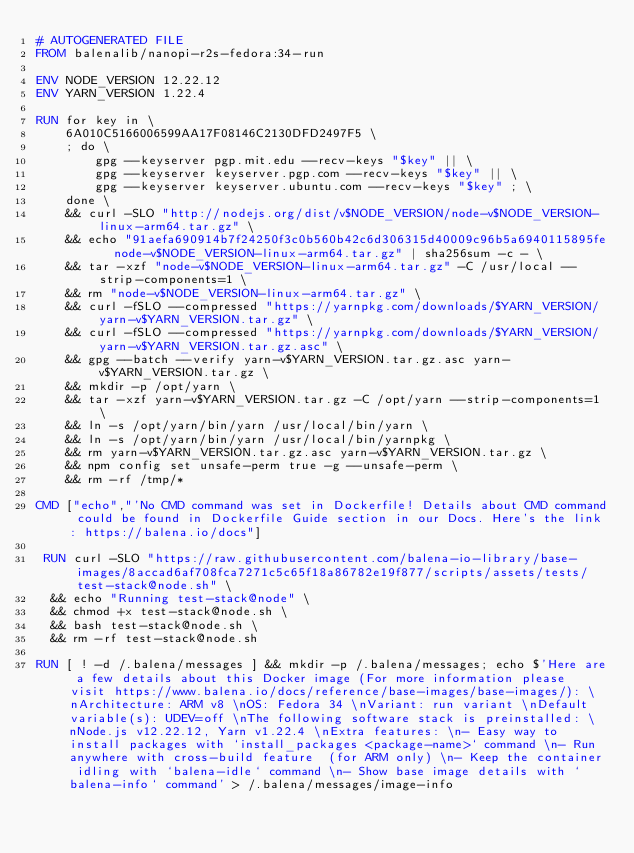<code> <loc_0><loc_0><loc_500><loc_500><_Dockerfile_># AUTOGENERATED FILE
FROM balenalib/nanopi-r2s-fedora:34-run

ENV NODE_VERSION 12.22.12
ENV YARN_VERSION 1.22.4

RUN for key in \
	6A010C5166006599AA17F08146C2130DFD2497F5 \
	; do \
		gpg --keyserver pgp.mit.edu --recv-keys "$key" || \
		gpg --keyserver keyserver.pgp.com --recv-keys "$key" || \
		gpg --keyserver keyserver.ubuntu.com --recv-keys "$key" ; \
	done \
	&& curl -SLO "http://nodejs.org/dist/v$NODE_VERSION/node-v$NODE_VERSION-linux-arm64.tar.gz" \
	&& echo "91aefa690914b7f24250f3c0b560b42c6d306315d40009c96b5a6940115895fe  node-v$NODE_VERSION-linux-arm64.tar.gz" | sha256sum -c - \
	&& tar -xzf "node-v$NODE_VERSION-linux-arm64.tar.gz" -C /usr/local --strip-components=1 \
	&& rm "node-v$NODE_VERSION-linux-arm64.tar.gz" \
	&& curl -fSLO --compressed "https://yarnpkg.com/downloads/$YARN_VERSION/yarn-v$YARN_VERSION.tar.gz" \
	&& curl -fSLO --compressed "https://yarnpkg.com/downloads/$YARN_VERSION/yarn-v$YARN_VERSION.tar.gz.asc" \
	&& gpg --batch --verify yarn-v$YARN_VERSION.tar.gz.asc yarn-v$YARN_VERSION.tar.gz \
	&& mkdir -p /opt/yarn \
	&& tar -xzf yarn-v$YARN_VERSION.tar.gz -C /opt/yarn --strip-components=1 \
	&& ln -s /opt/yarn/bin/yarn /usr/local/bin/yarn \
	&& ln -s /opt/yarn/bin/yarn /usr/local/bin/yarnpkg \
	&& rm yarn-v$YARN_VERSION.tar.gz.asc yarn-v$YARN_VERSION.tar.gz \
	&& npm config set unsafe-perm true -g --unsafe-perm \
	&& rm -rf /tmp/*

CMD ["echo","'No CMD command was set in Dockerfile! Details about CMD command could be found in Dockerfile Guide section in our Docs. Here's the link: https://balena.io/docs"]

 RUN curl -SLO "https://raw.githubusercontent.com/balena-io-library/base-images/8accad6af708fca7271c5c65f18a86782e19f877/scripts/assets/tests/test-stack@node.sh" \
  && echo "Running test-stack@node" \
  && chmod +x test-stack@node.sh \
  && bash test-stack@node.sh \
  && rm -rf test-stack@node.sh 

RUN [ ! -d /.balena/messages ] && mkdir -p /.balena/messages; echo $'Here are a few details about this Docker image (For more information please visit https://www.balena.io/docs/reference/base-images/base-images/): \nArchitecture: ARM v8 \nOS: Fedora 34 \nVariant: run variant \nDefault variable(s): UDEV=off \nThe following software stack is preinstalled: \nNode.js v12.22.12, Yarn v1.22.4 \nExtra features: \n- Easy way to install packages with `install_packages <package-name>` command \n- Run anywhere with cross-build feature  (for ARM only) \n- Keep the container idling with `balena-idle` command \n- Show base image details with `balena-info` command' > /.balena/messages/image-info</code> 